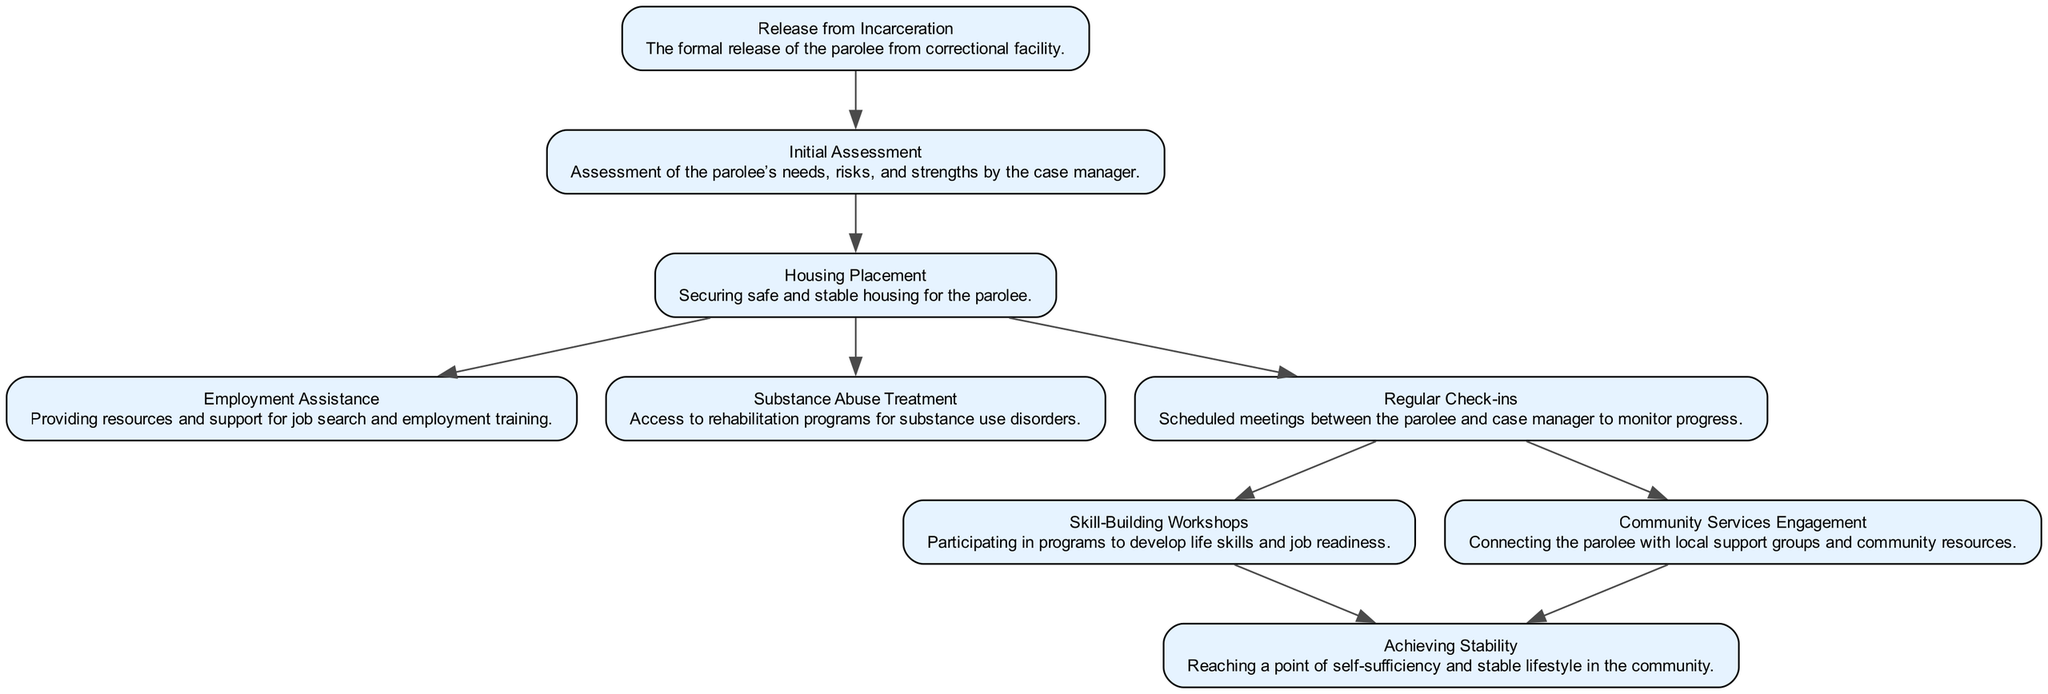What is the first step in the reintegration journey? The first step shown in the diagram is the "Release from Incarceration" node, which marks the beginning of the parolee's reintegration process.
Answer: Release from Incarceration How many total nodes are present in the diagram? By counting the elements defined in the diagram, there are nine distinct nodes that represent different stages in the parolee's journey.
Answer: 9 What is the relationship between the "Initial Assessment" and "Housing Placement"? The diagram shows a direct connection (edge) from the "Initial Assessment" node to the "Housing Placement" node, indicating that the assessment leads to housing arrangements.
Answer: Direct connection Which node must the parolee go through after "Regular Check-ins"? Following "Regular Check-ins," the parolee must choose between "Skill-Building Workshops" and "Community Services Engagement," both of which indicate further steps in the reintegration process.
Answer: Skill-Building Workshops or Community Services Engagement What is the final goal of the reintegration journey? The final goal, as depicted in the diagram, is represented by the "Achieving Stability" node, which signifies reaching a stable lifestyle in the community.
Answer: Achieving Stability How many edges are connected to the "Housing Placement" node? Upon examining the connections, the "Housing Placement" node is connected to three edges leading to "Employment Assistance," "Substance Abuse Treatment," and "Regular Check-ins."
Answer: 3 What is the significance of the "Substance Abuse Treatment" node? The "Substance Abuse Treatment" node is critical as it is linked to the "Housing Placement" node, showing that access to treatment may follow securing stable housing, crucial for achieving stability.
Answer: Treatment for substance use disorders Which nodes provide pathways to "Achieving Stability"? The diagram indicates that both "Skill-Building Workshops" and "Community Services Engagement" provide direct pathways (edges) to the "Achieving Stability" node, emphasizing their roles in the reintegration process.
Answer: Skill-Building Workshops, Community Services Engagement 